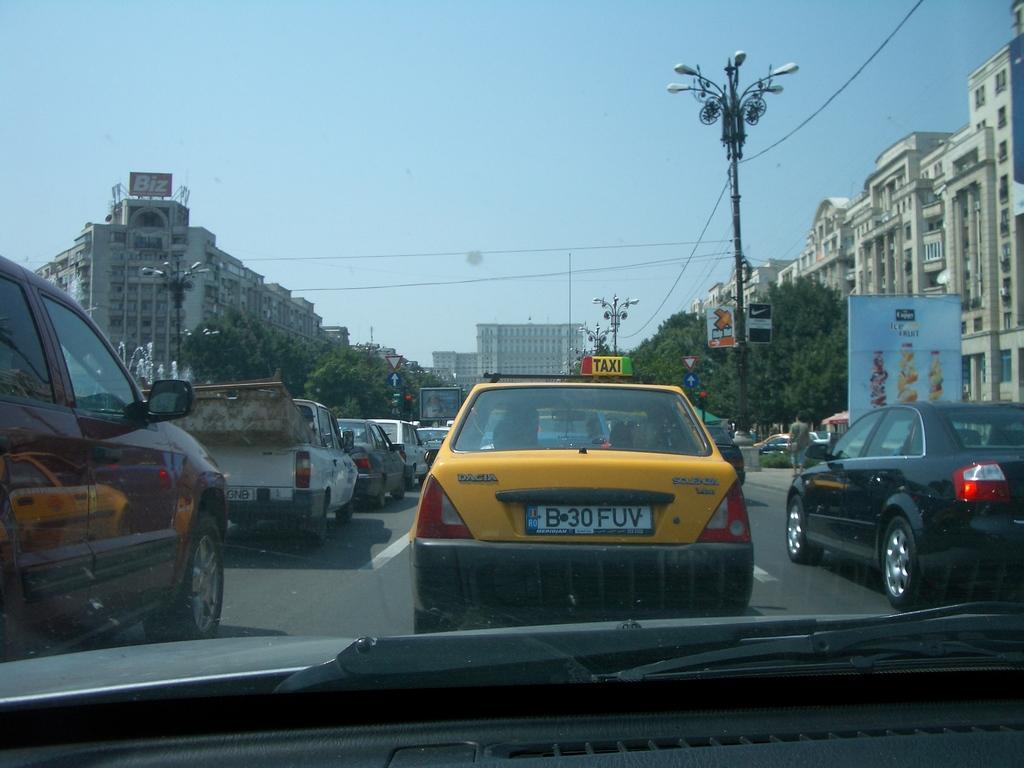Please provide a concise description of this image. In the picture I can see few vehicles on the road and there are trees,buildings on either sides of it. 